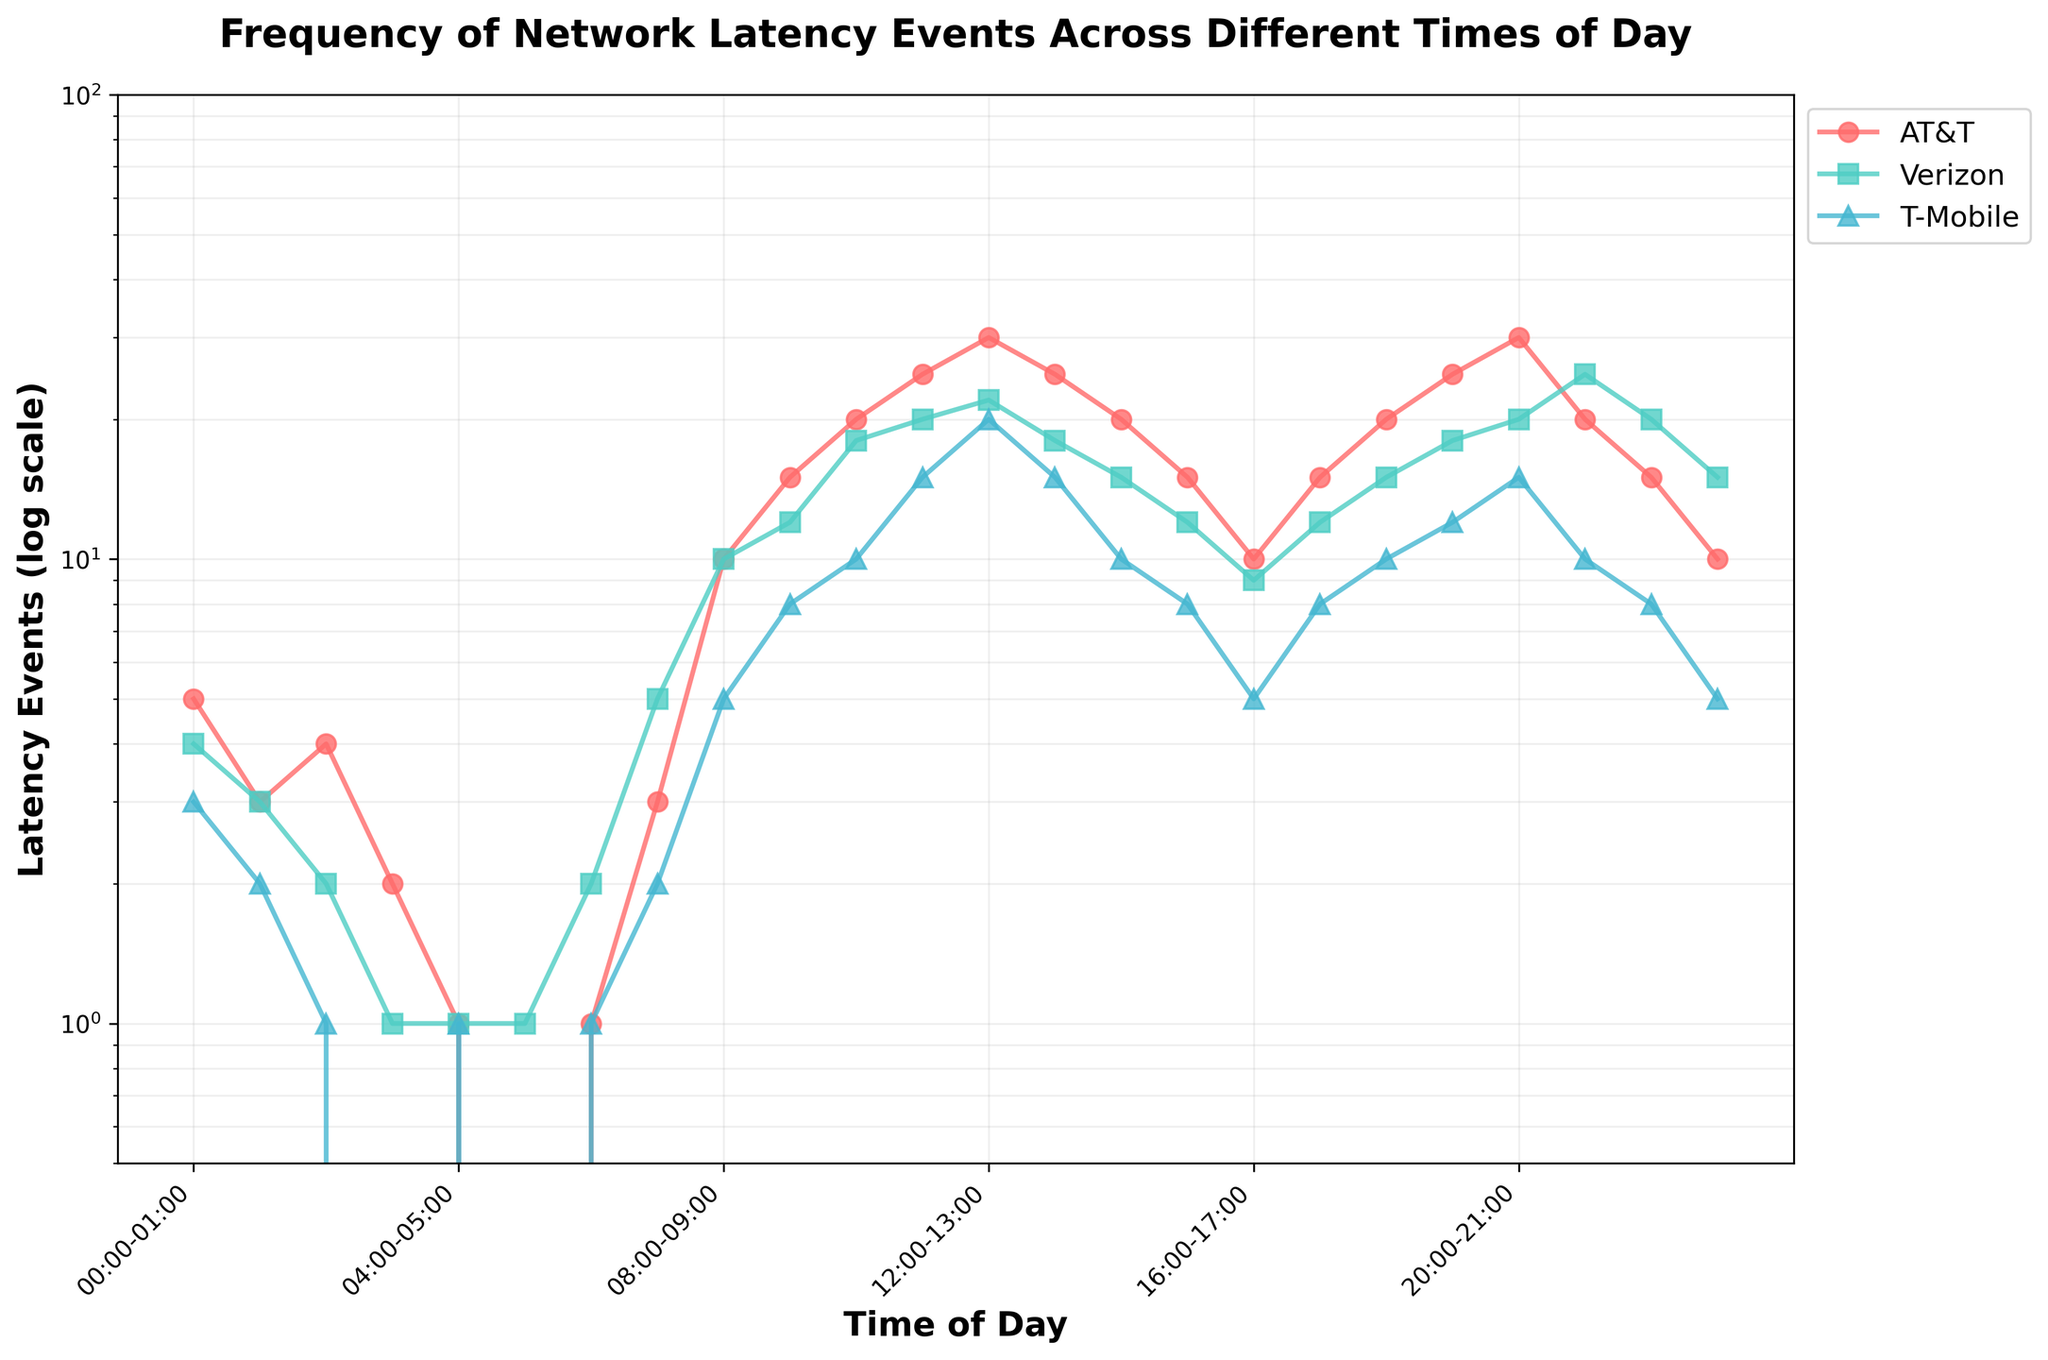What is the title of the figure? The title is usually placed at the top of the figure and is written in a larger, bold font. Looking at the figure, the title reads "Frequency of Network Latency Events Across Different Times of Day."
Answer: Frequency of Network Latency Events Across Different Times of Day What is the label on the x-axis? The x-axis label is found along the horizontal axis of the figure and is usually written in bold. According to the plot, it says "Time of Day."
Answer: Time of Day How many networks are represented in the figure? By examining the legend or the lines plotted, we can see there are three distinct colors, each representing a different network. The legend shows three network names: AT&T, Verizon, and T-Mobile.
Answer: 3 Which network has the highest number of latency events at 12:00-13:00? Looking at the plotted points around 12:00-13:00, we see that AT&T has a value of 30, Verizon has 22, and T-Mobile has 20. Therefore, AT&T has the highest number of latency events at this time.
Answer: AT&T What is the lowest number of latency events recorded for any network and at what time does it occur? The minimum value on the y-axis (log scale) indicates 0 latency events at 05:00-06:00 for AT&T and 03:00-04:00 for T-Mobile.
Answer: 0, 05:00-06:00 for AT&T and 03:00-04:00 for T-Mobile How does the number of latency events change for Verizon from 08:00-09:00 to 12:00-13:00? To determine the change, subtract the number of latency events at 08:00-09:00 from those at 12:00-13:00 for Verizon. From the plot, at 08:00-09:00 Verizon has 10 latency events, and at 12:00-13:00, it has 22. So, the change is 22 - 10 = 12.
Answer: Increase by 12 At what times of the day does T-Mobile consistently record zero latency events? By examining the T-Mobile plot line or points below 1 on the log scale, T-Mobile has zero latency events at 03:00-04:00 and 05:00-06:00.
Answer: 03:00-04:00 and 05:00-06:00 Which network peaks at 21:00-22:00, and what is the number of latency events recorded? At 21:00-22:00, observe the points; the peak value is for Verizon with 25 latency events.
Answer: Verizon, 25 Between 11:00-12:00 and 15:00-16:00, which network shows the greatest reduction in latency events? Calculate the differences for each network. AT&T decreases from 25 to 15 (25 - 15 = 10), Verizon from 20 to 12 (20 - 12 = 8), and T-Mobile from 15 to 8 (15 - 8 = 7). AT&T shows the greatest reduction.
Answer: AT&T Comparing the peak hours for each network, which network has the latest peak in latency events? Identify the highest values and their corresponding times for each network: AT&T peaks at 20:00-21:00 with 30 events, Verizon peaks at 21:00-22:00 with 25 events, and T-Mobile peaks at 20:00-21:00 with 15 events. The latest peak is for Verizon at 21:00-22:00.
Answer: Verizon 